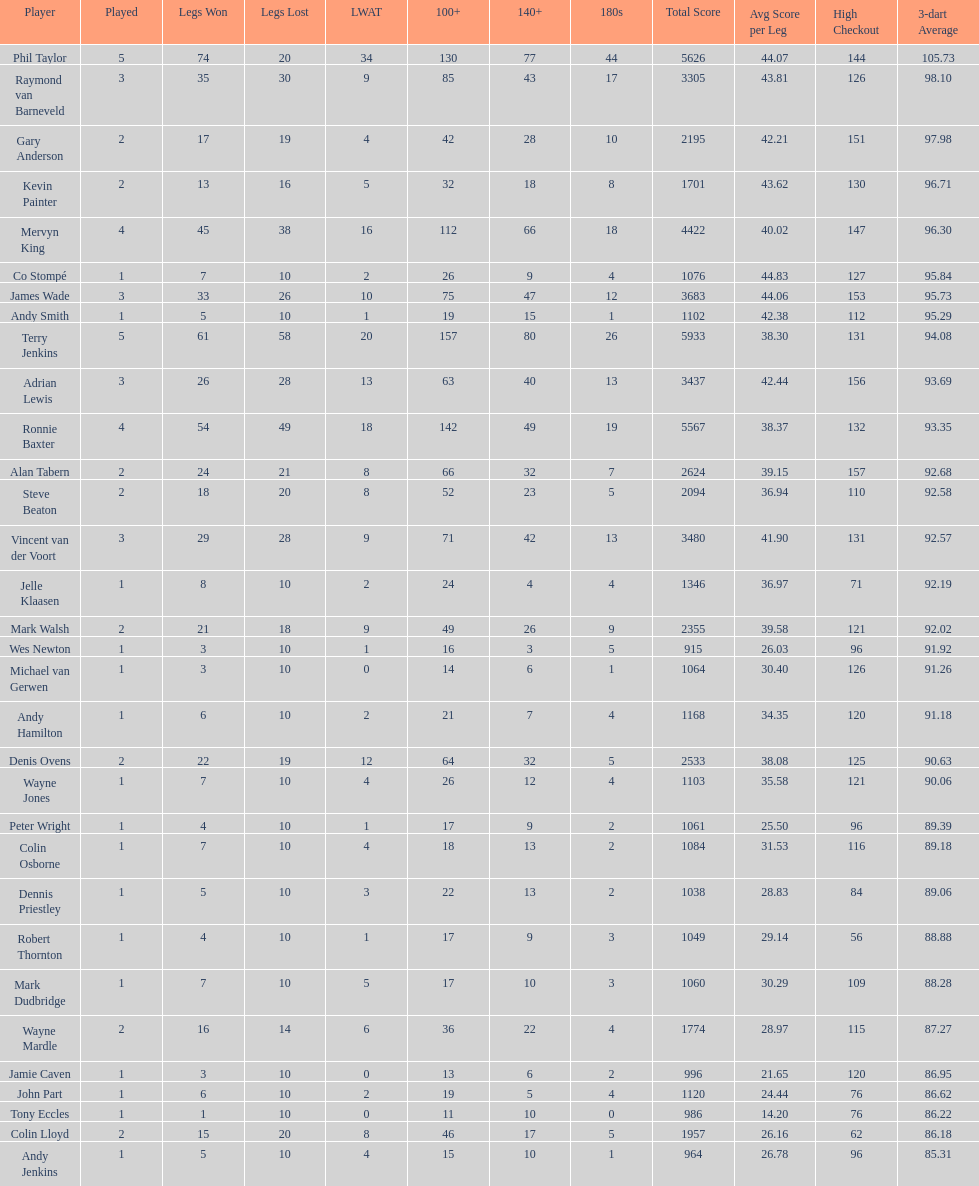What is the name of the following participant after mark walsh? Wes Newton. 